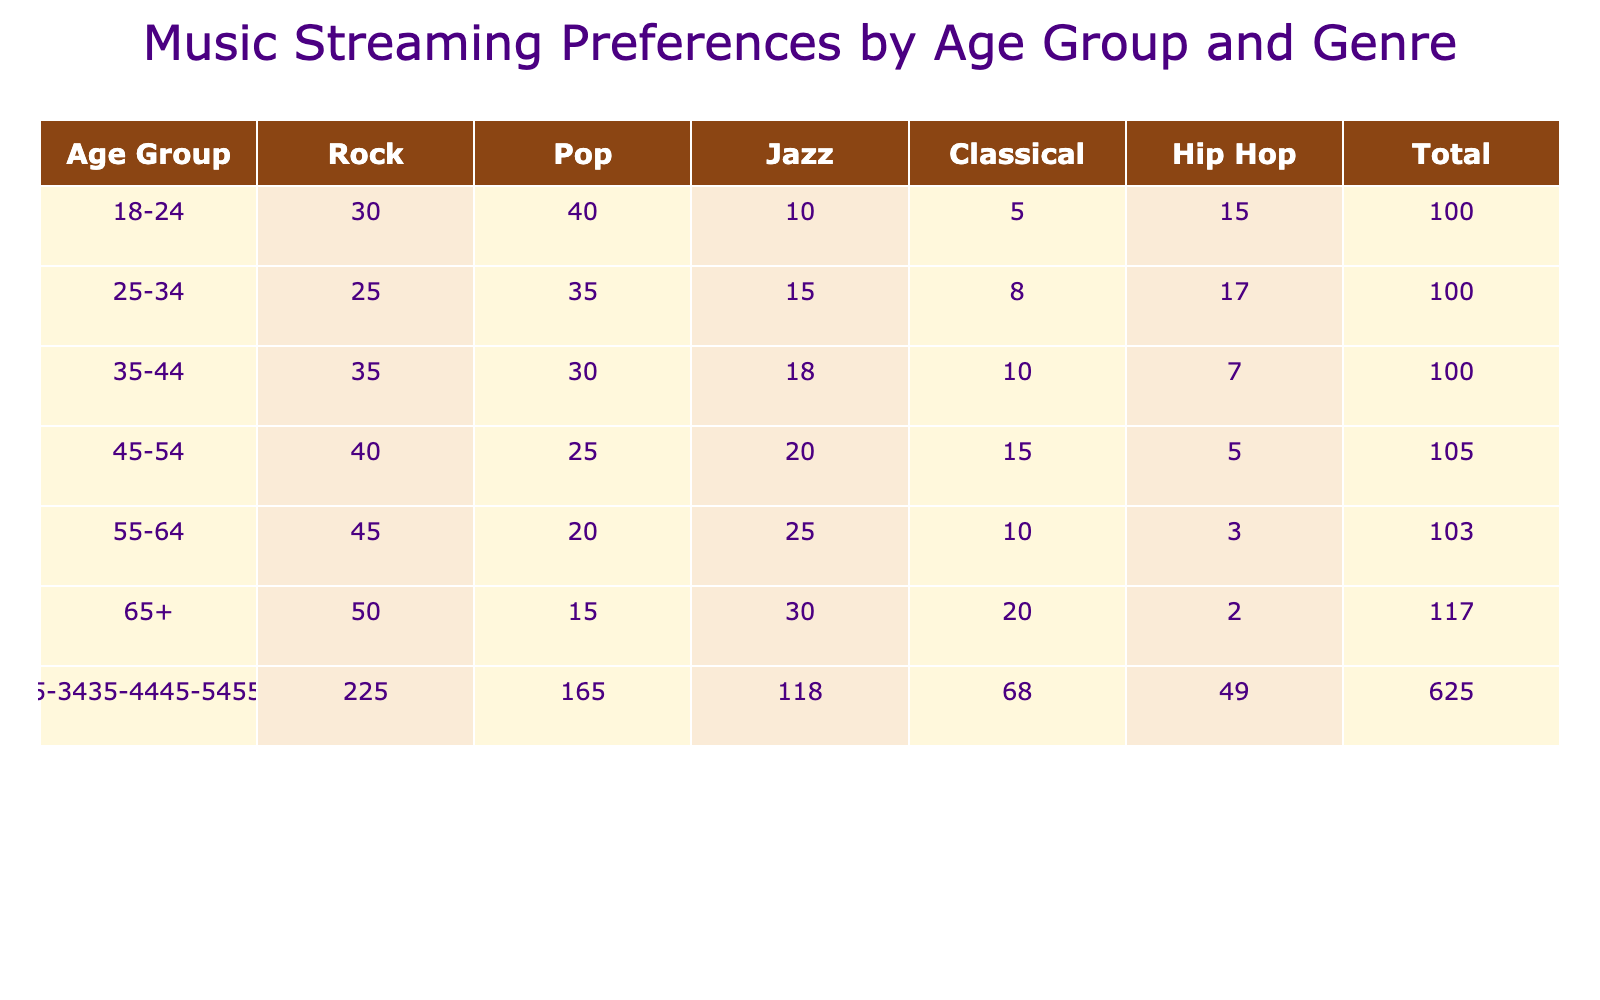What age group has the highest preference for Rock music? The highest number for Rock music is found in the age group 65+ with a preference of 50. By comparing all the rows for Rock, this number is the largest.
Answer: 65+ What is the total number of Jazz listeners across all age groups? To determine the total for Jazz, we sum the values from the Jazz column: 10 + 15 + 18 + 20 + 25 + 30 = 118.
Answer: 118 Which genre has the lowest preference among the 55-64 age group? In the 55-64 age group, the genre Hip Hop has the lowest value of 3, compared to Rock (45), Pop (20), Jazz (25), and Classical (10).
Answer: Hip Hop Is there any age group that prefers Pop music more than Rock music? Analyzing the Pop values, the 18-24 age group (40) and the 25-34 age group (35) have Pop values greater than their Rock preferences of 30 and 25 respectively. Thus, two age groups prefer Pop over Rock.
Answer: Yes What is the average preference for Classical music across all age groups? We find the values for Classical: 5, 8, 10, 15, 20, 25. Adding these gives 83. There are 6 groups, so we divide 83 by 6, which is approximately 13.83.
Answer: 13.83 What age group shows a notable preference for Hip Hop compared to others? Looking at the Hip Hop values, the 25-34 age group (17) has a relatively high preference compared to the 45-54 group (5) and 55-64 group (3). However, 18-24 (15) and 35-44 (7) also show lower preference compared to 25-34. Hence, 25-34 is noted for its stronger preference.
Answer: 25-34 How many more people in the 35-44 age group prefer Rock compared to Pop? The Rock preference for the 35-44 age group is 35, while Pop is 30. The difference is 35 - 30 = 5.
Answer: 5 What genre is most popular in the 45-54 age group? In the 45-54 age group, we look at the numbers: Rock (40), Pop (25), Jazz (20), Classical (15), Hip Hop (5). The highest is Rock, with a value of 40.
Answer: Rock Which genre has seen a decline in preference as age increases? Analyzing the data, Hip Hop shows a clear decline from 15 in the 18-24 group down to 2 in the 65+ group, indicating a decreasing trend of preference with age.
Answer: Hip Hop 